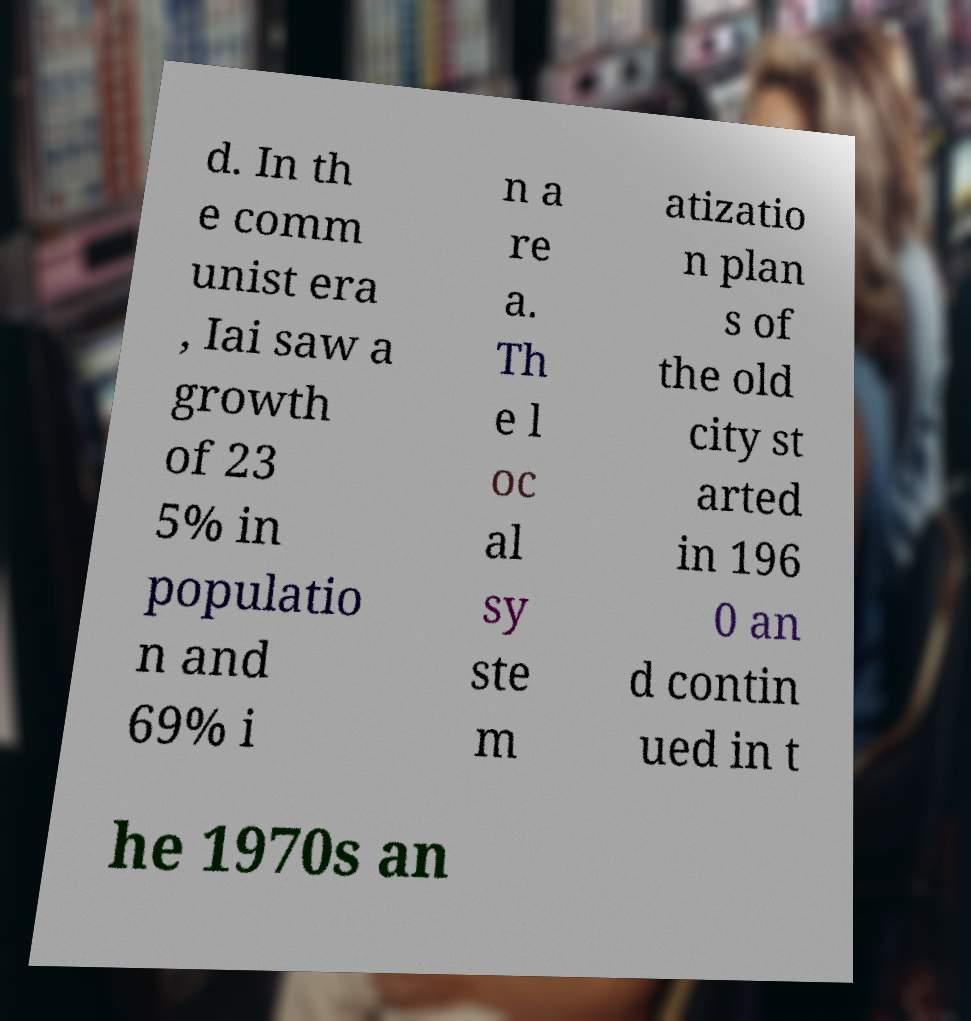Could you extract and type out the text from this image? d. In th e comm unist era , Iai saw a growth of 23 5% in populatio n and 69% i n a re a. Th e l oc al sy ste m atizatio n plan s of the old city st arted in 196 0 an d contin ued in t he 1970s an 